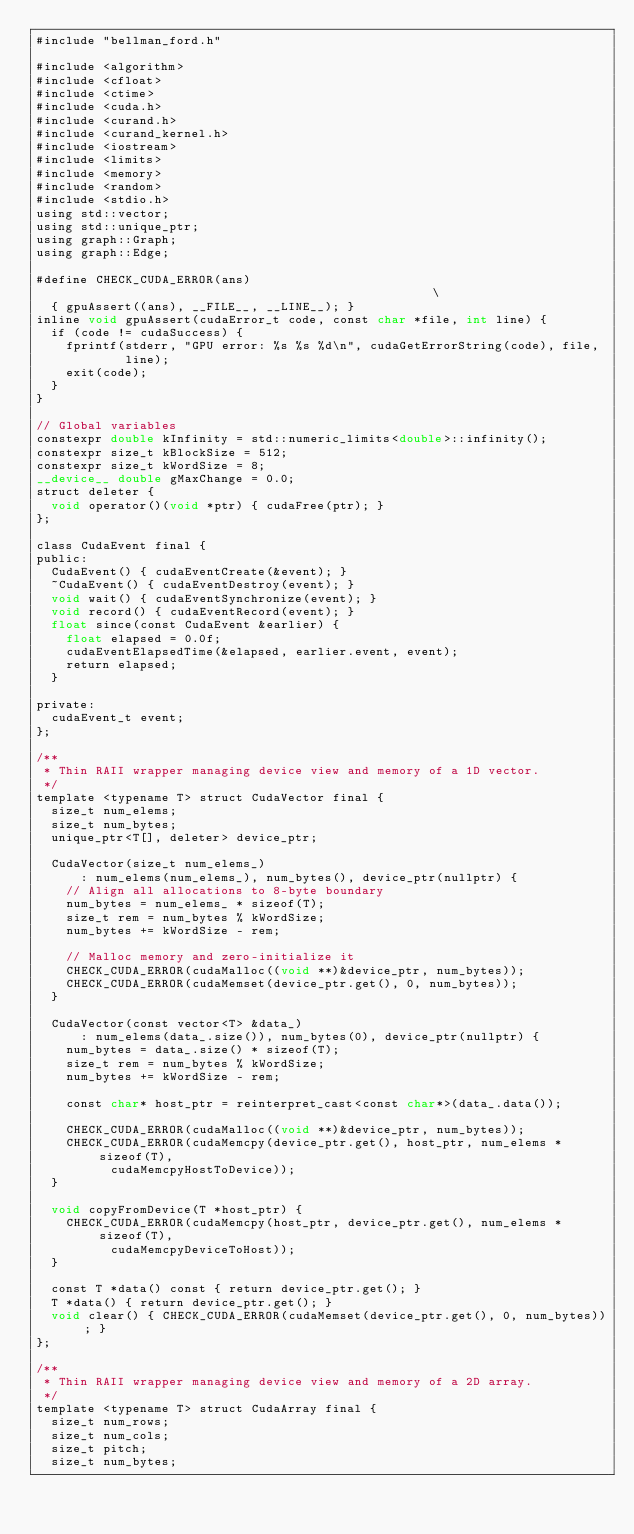Convert code to text. <code><loc_0><loc_0><loc_500><loc_500><_Cuda_>#include "bellman_ford.h"

#include <algorithm>
#include <cfloat>
#include <ctime>
#include <cuda.h>
#include <curand.h>
#include <curand_kernel.h>
#include <iostream>
#include <limits>
#include <memory>
#include <random>
#include <stdio.h>
using std::vector;
using std::unique_ptr;
using graph::Graph;
using graph::Edge;

#define CHECK_CUDA_ERROR(ans)                                                  \
  { gpuAssert((ans), __FILE__, __LINE__); }
inline void gpuAssert(cudaError_t code, const char *file, int line) {
  if (code != cudaSuccess) {
    fprintf(stderr, "GPU error: %s %s %d\n", cudaGetErrorString(code), file,
            line);
    exit(code);
  }
}

// Global variables
constexpr double kInfinity = std::numeric_limits<double>::infinity();
constexpr size_t kBlockSize = 512;
constexpr size_t kWordSize = 8;
__device__ double gMaxChange = 0.0;
struct deleter {
  void operator()(void *ptr) { cudaFree(ptr); }
};

class CudaEvent final {
public:
  CudaEvent() { cudaEventCreate(&event); }
  ~CudaEvent() { cudaEventDestroy(event); }
  void wait() { cudaEventSynchronize(event); }
  void record() { cudaEventRecord(event); }
  float since(const CudaEvent &earlier) {
    float elapsed = 0.0f;
    cudaEventElapsedTime(&elapsed, earlier.event, event);
    return elapsed;
  }

private:
  cudaEvent_t event;
};

/**
 * Thin RAII wrapper managing device view and memory of a 1D vector.
 */
template <typename T> struct CudaVector final {
  size_t num_elems;
  size_t num_bytes;
  unique_ptr<T[], deleter> device_ptr;

  CudaVector(size_t num_elems_)
      : num_elems(num_elems_), num_bytes(), device_ptr(nullptr) {
    // Align all allocations to 8-byte boundary
    num_bytes = num_elems_ * sizeof(T);
    size_t rem = num_bytes % kWordSize;
    num_bytes += kWordSize - rem;

    // Malloc memory and zero-initialize it
    CHECK_CUDA_ERROR(cudaMalloc((void **)&device_ptr, num_bytes));
    CHECK_CUDA_ERROR(cudaMemset(device_ptr.get(), 0, num_bytes));
  }

  CudaVector(const vector<T> &data_)
      : num_elems(data_.size()), num_bytes(0), device_ptr(nullptr) {
    num_bytes = data_.size() * sizeof(T);
    size_t rem = num_bytes % kWordSize;
    num_bytes += kWordSize - rem;

    const char* host_ptr = reinterpret_cast<const char*>(data_.data());

    CHECK_CUDA_ERROR(cudaMalloc((void **)&device_ptr, num_bytes));
    CHECK_CUDA_ERROR(cudaMemcpy(device_ptr.get(), host_ptr, num_elems * sizeof(T),
          cudaMemcpyHostToDevice));
  }

  void copyFromDevice(T *host_ptr) {
    CHECK_CUDA_ERROR(cudaMemcpy(host_ptr, device_ptr.get(), num_elems * sizeof(T),
          cudaMemcpyDeviceToHost));
  }

  const T *data() const { return device_ptr.get(); }
  T *data() { return device_ptr.get(); }
  void clear() { CHECK_CUDA_ERROR(cudaMemset(device_ptr.get(), 0, num_bytes)); }
};

/**
 * Thin RAII wrapper managing device view and memory of a 2D array.
 */
template <typename T> struct CudaArray final {
  size_t num_rows;
  size_t num_cols;
  size_t pitch;
  size_t num_bytes;</code> 